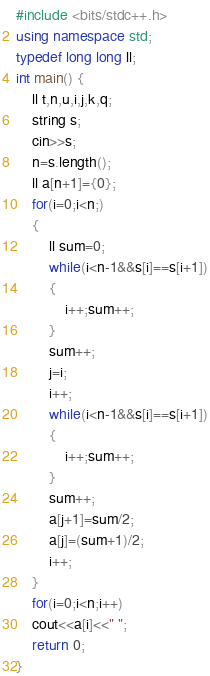Convert code to text. <code><loc_0><loc_0><loc_500><loc_500><_C++_>#include <bits/stdc++.h>
using namespace std;
typedef long long ll;
int main() {
	ll t,n,u,i,j,k,q;
	string s;
	cin>>s;
	n=s.length();
	ll a[n+1]={0};
	for(i=0;i<n;)
	{
	    ll sum=0;
	    while(i<n-1&&s[i]==s[i+1])
	    {
	        i++;sum++;
	    }
	    sum++;
	    j=i;
	    i++;
	    while(i<n-1&&s[i]==s[i+1])
	    {
	        i++;sum++;
	    }
	    sum++;
	    a[j+1]=sum/2;
	    a[j]=(sum+1)/2;
	    i++;
	}
	for(i=0;i<n;i++)
	cout<<a[i]<<" ";
	return 0;
}</code> 